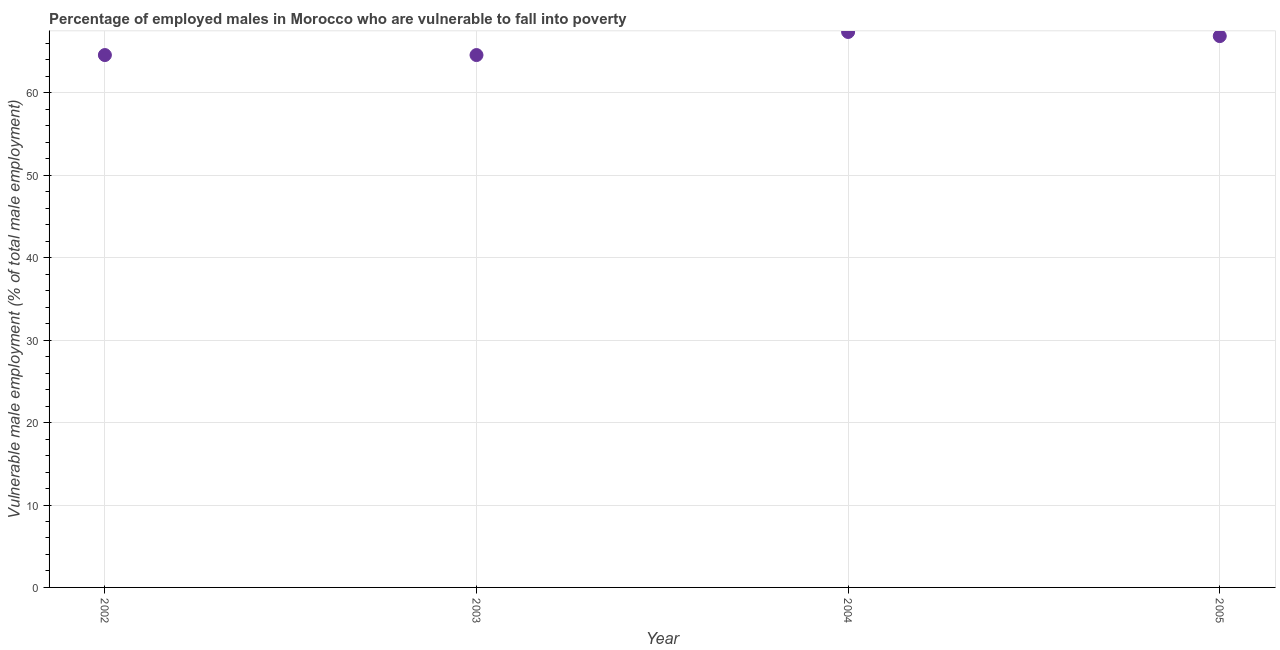What is the percentage of employed males who are vulnerable to fall into poverty in 2003?
Provide a succinct answer. 64.6. Across all years, what is the maximum percentage of employed males who are vulnerable to fall into poverty?
Offer a very short reply. 67.4. Across all years, what is the minimum percentage of employed males who are vulnerable to fall into poverty?
Offer a very short reply. 64.6. What is the sum of the percentage of employed males who are vulnerable to fall into poverty?
Give a very brief answer. 263.5. What is the difference between the percentage of employed males who are vulnerable to fall into poverty in 2002 and 2003?
Give a very brief answer. 0. What is the average percentage of employed males who are vulnerable to fall into poverty per year?
Offer a terse response. 65.87. What is the median percentage of employed males who are vulnerable to fall into poverty?
Keep it short and to the point. 65.75. What is the ratio of the percentage of employed males who are vulnerable to fall into poverty in 2002 to that in 2004?
Ensure brevity in your answer.  0.96. What is the difference between the highest and the second highest percentage of employed males who are vulnerable to fall into poverty?
Your response must be concise. 0.5. Is the sum of the percentage of employed males who are vulnerable to fall into poverty in 2003 and 2005 greater than the maximum percentage of employed males who are vulnerable to fall into poverty across all years?
Provide a short and direct response. Yes. What is the difference between the highest and the lowest percentage of employed males who are vulnerable to fall into poverty?
Offer a terse response. 2.8. Does the percentage of employed males who are vulnerable to fall into poverty monotonically increase over the years?
Offer a terse response. No. How many dotlines are there?
Offer a very short reply. 1. How many years are there in the graph?
Give a very brief answer. 4. Does the graph contain any zero values?
Offer a terse response. No. What is the title of the graph?
Provide a succinct answer. Percentage of employed males in Morocco who are vulnerable to fall into poverty. What is the label or title of the Y-axis?
Offer a very short reply. Vulnerable male employment (% of total male employment). What is the Vulnerable male employment (% of total male employment) in 2002?
Make the answer very short. 64.6. What is the Vulnerable male employment (% of total male employment) in 2003?
Give a very brief answer. 64.6. What is the Vulnerable male employment (% of total male employment) in 2004?
Your answer should be compact. 67.4. What is the Vulnerable male employment (% of total male employment) in 2005?
Your response must be concise. 66.9. What is the difference between the Vulnerable male employment (% of total male employment) in 2002 and 2003?
Provide a short and direct response. 0. What is the difference between the Vulnerable male employment (% of total male employment) in 2004 and 2005?
Offer a terse response. 0.5. What is the ratio of the Vulnerable male employment (% of total male employment) in 2002 to that in 2003?
Give a very brief answer. 1. What is the ratio of the Vulnerable male employment (% of total male employment) in 2002 to that in 2004?
Offer a terse response. 0.96. What is the ratio of the Vulnerable male employment (% of total male employment) in 2002 to that in 2005?
Offer a very short reply. 0.97. What is the ratio of the Vulnerable male employment (% of total male employment) in 2003 to that in 2004?
Your response must be concise. 0.96. 